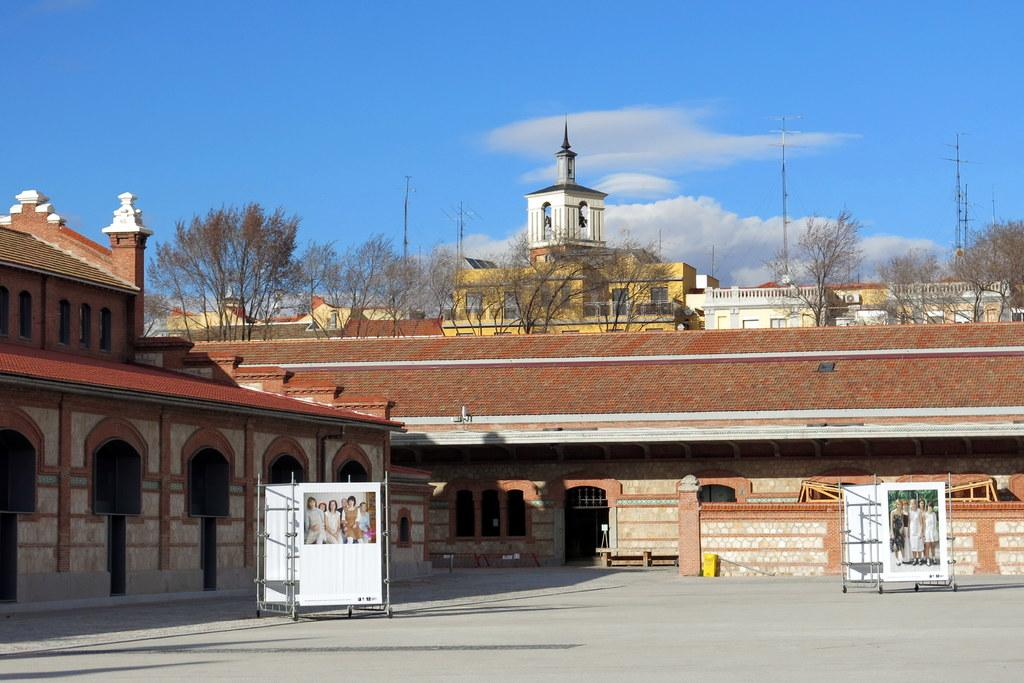What can be seen in the sky in the image? The sky with clouds is visible in the image. What type of structures are present in the image? There are buildings in the image. What are the advertisement stands used for in the image? Advertisement stands are present in the image for displaying advertisements or promotional materials. What part of the buildings can be seen in the image? Windows are visible in the image. What type of vegetation is present in the image? Trees are present in the image. What are the poles used for in the image? Poles are visible in the image, but their purpose is not specified. What type of cake is being served at the destruction site in the image? There is no destruction site or cake present in the image. What date is marked on the calendar in the image? There is no calendar present in the image. 